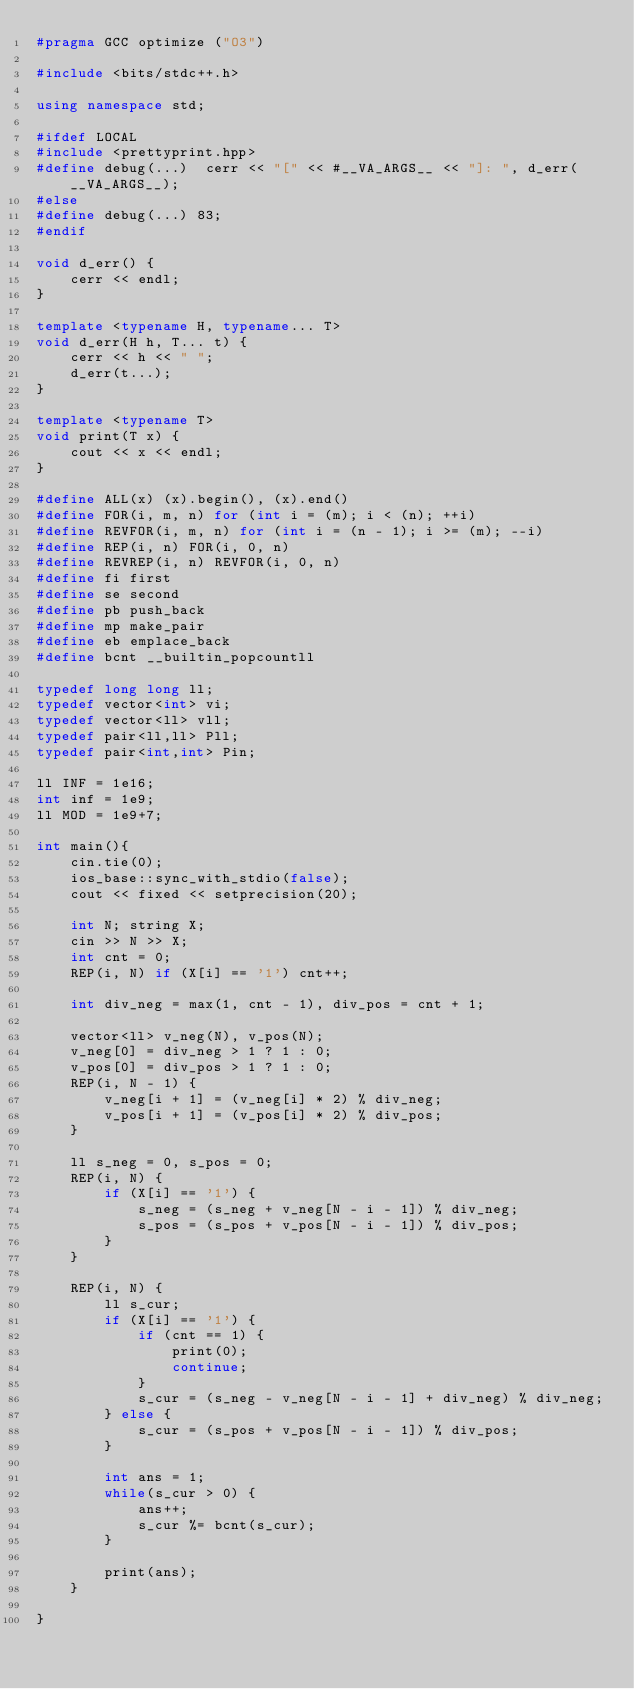Convert code to text. <code><loc_0><loc_0><loc_500><loc_500><_C++_>#pragma GCC optimize ("O3")

#include <bits/stdc++.h>

using namespace std;

#ifdef LOCAL
#include <prettyprint.hpp>
#define debug(...)  cerr << "[" << #__VA_ARGS__ << "]: ", d_err(__VA_ARGS__);
#else
#define debug(...) 83;
#endif

void d_err() {
    cerr << endl;
}

template <typename H, typename... T>
void d_err(H h, T... t) {
    cerr << h << " ";
    d_err(t...);
}

template <typename T>
void print(T x) {
    cout << x << endl;
}

#define ALL(x) (x).begin(), (x).end()
#define FOR(i, m, n) for (int i = (m); i < (n); ++i)
#define REVFOR(i, m, n) for (int i = (n - 1); i >= (m); --i)
#define REP(i, n) FOR(i, 0, n)
#define REVREP(i, n) REVFOR(i, 0, n)
#define fi first
#define se second
#define pb push_back
#define mp make_pair
#define eb emplace_back
#define bcnt __builtin_popcountll

typedef long long ll;
typedef vector<int> vi;
typedef vector<ll> vll;
typedef pair<ll,ll> Pll;
typedef pair<int,int> Pin;

ll INF = 1e16;
int inf = 1e9;
ll MOD = 1e9+7;

int main(){
    cin.tie(0);
    ios_base::sync_with_stdio(false);
    cout << fixed << setprecision(20);

    int N; string X;
    cin >> N >> X;
    int cnt = 0;
    REP(i, N) if (X[i] == '1') cnt++;

    int div_neg = max(1, cnt - 1), div_pos = cnt + 1;

    vector<ll> v_neg(N), v_pos(N);
    v_neg[0] = div_neg > 1 ? 1 : 0;
    v_pos[0] = div_pos > 1 ? 1 : 0;
    REP(i, N - 1) {
        v_neg[i + 1] = (v_neg[i] * 2) % div_neg;
        v_pos[i + 1] = (v_pos[i] * 2) % div_pos;
    }

    ll s_neg = 0, s_pos = 0;
    REP(i, N) {
        if (X[i] == '1') {
            s_neg = (s_neg + v_neg[N - i - 1]) % div_neg;
            s_pos = (s_pos + v_pos[N - i - 1]) % div_pos;
        }
    }

    REP(i, N) {
        ll s_cur;
        if (X[i] == '1') {
            if (cnt == 1) {
                print(0);
                continue;
            }
            s_cur = (s_neg - v_neg[N - i - 1] + div_neg) % div_neg;
        } else {
            s_cur = (s_pos + v_pos[N - i - 1]) % div_pos;
        }

        int ans = 1;
        while(s_cur > 0) {
            ans++;
            s_cur %= bcnt(s_cur);
        }

        print(ans);
    }

}
</code> 